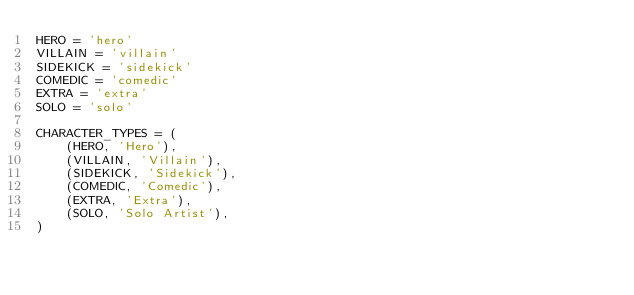<code> <loc_0><loc_0><loc_500><loc_500><_Python_>HERO = 'hero'
VILLAIN = 'villain'
SIDEKICK = 'sidekick'
COMEDIC = 'comedic'
EXTRA = 'extra'
SOLO = 'solo'

CHARACTER_TYPES = (
    (HERO, 'Hero'),
    (VILLAIN, 'Villain'),
    (SIDEKICK, 'Sidekick'),
    (COMEDIC, 'Comedic'),
    (EXTRA, 'Extra'),
    (SOLO, 'Solo Artist'),
)
</code> 